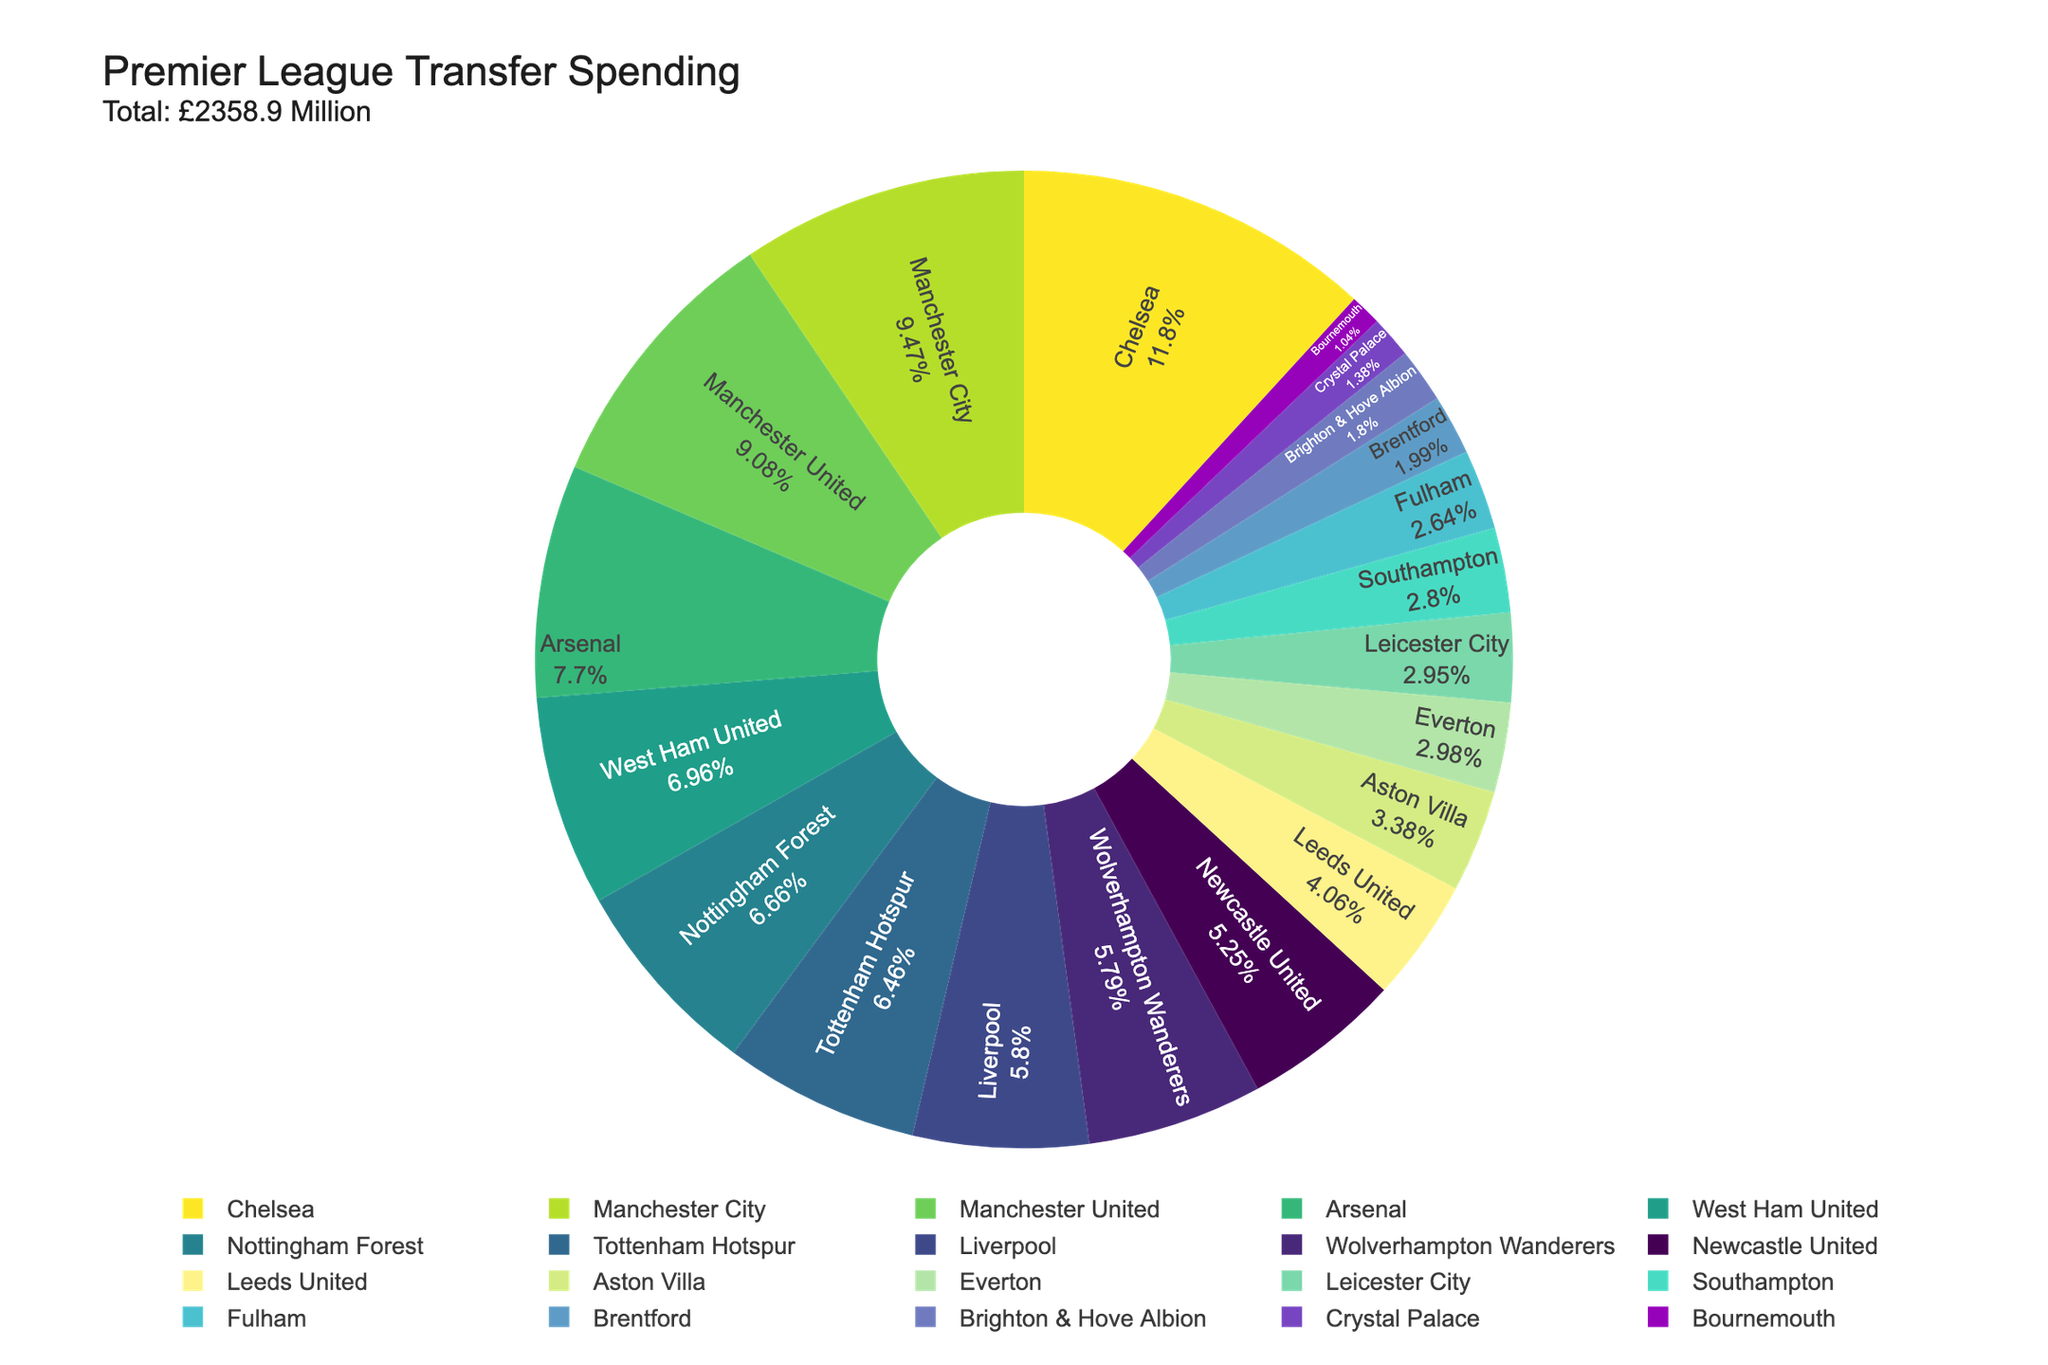Which team spent the most on transfers? By examining the segment in the pie chart with the largest portion, we can identify the team that spent the most. Based on the figure, Chelsea has the largest segment.
Answer: Chelsea Which two teams spent the least on transfers? The smallest segments in the pie chart represent the teams that spent the least on transfers. According to the figure, Bournemouth and Crystal Palace have the smallest segments.
Answer: Bournemouth and Crystal Palace How does Manchester City's spending compare to Arsenal's? To compare their spending, we look at the relative sizes of their segments in the pie chart. Manchester City's segment is larger than Arsenal's, indicating higher spending.
Answer: Manchester City spent more than Arsenal What's the combined spending of Liverpool and Tottenham Hotspur? By looking at the pie chart, identify the segments for Liverpool and Tottenham Hotspur, then add their values: 136.9 + 152.3 = 289.2
Answer: £289.2 Million What percentage of the total spending was done by Manchester United? Identify the segment for Manchester United and refer to the percentage shown on the chart. The pie chart shows Manchester United's segment as 214.2/2828.9 ≈ 7.6%.
Answer: 7.6% How much more did Chelsea spend compared to Nottingham Forest? Identify the spending values from the pie chart segments for Chelsea and Nottingham Forest, then calculate the difference: 278.4 - 157.2 = 121.2
Answer: £121.2 Million Are there more teams with spending above or below £100 Million? By referencing each segment on the pie chart, count the number of teams with spending above £100 Million and those below. There are 10 teams above and 10 teams below £100 Million.
Answer: Equal What's the total spending of the top three spending teams? Identify the top three segments by size (Chelsea, Manchester City, and Manchester United) and sum their spending values: 278.4 + 223.5 + 214.2 = 716.1
Answer: £716.1 Million Which team's spending is closest to £100 Million? Find the segment in the pie chart that represents the team's spending closest to £100 Million. Leeds United's segment shows spending of 95.8, which is closest to £100 Million.
Answer: Leeds United 